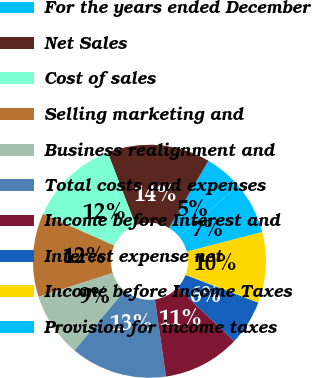Convert chart to OTSL. <chart><loc_0><loc_0><loc_500><loc_500><pie_chart><fcel>For the years ended December<fcel>Net Sales<fcel>Cost of sales<fcel>Selling marketing and<fcel>Business realignment and<fcel>Total costs and expenses<fcel>Income before Interest and<fcel>Interest expense net<fcel>Income before Income Taxes<fcel>Provision for income taxes<nl><fcel>5.36%<fcel>14.29%<fcel>12.5%<fcel>11.61%<fcel>8.93%<fcel>13.39%<fcel>10.71%<fcel>6.25%<fcel>9.82%<fcel>7.14%<nl></chart> 